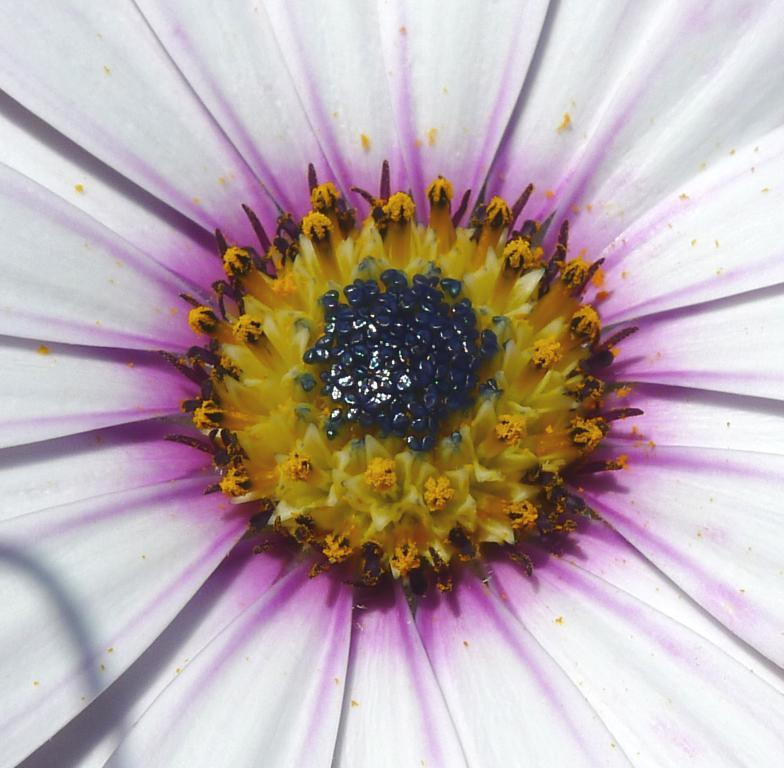What is the main subject of the image? The main subject of the image is a flower. Can you tell me how many horses are depicted in the image? There are no horses depicted in the image; it features a flower. What type of lipstick is the horse wearing in the image? There is no horse present in the image, and therefore no lipstick can be observed. 